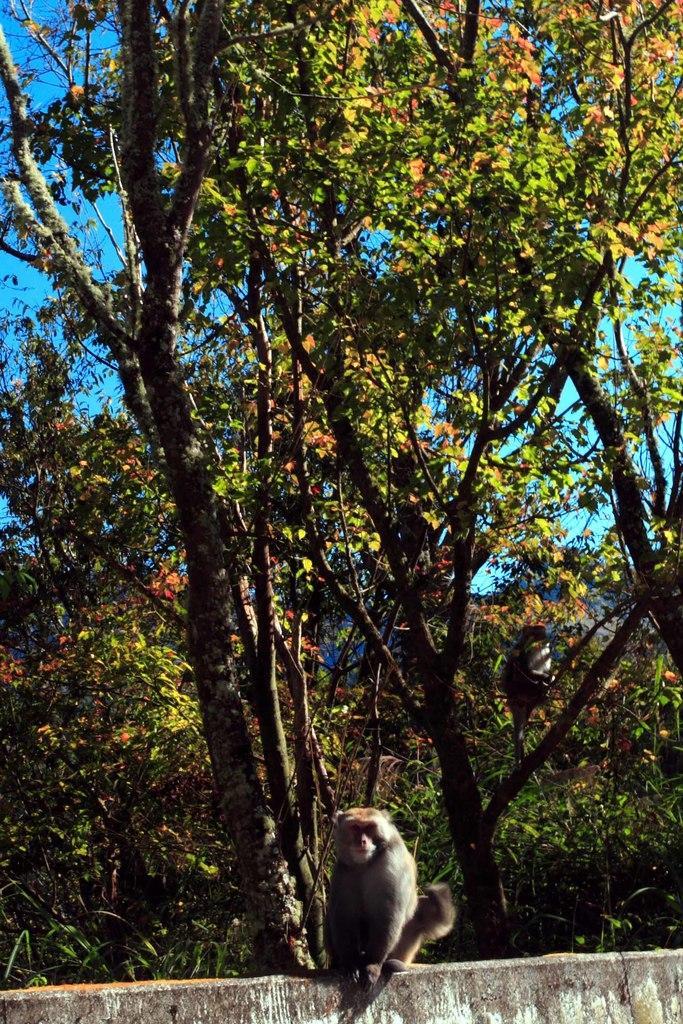How would you summarize this image in a sentence or two? In this image there is a wall in the foreground. There is a monkey. There are trees. We can see a bird. There is sky. 